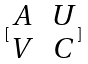<formula> <loc_0><loc_0><loc_500><loc_500>[ \begin{matrix} A & U \\ V & C \end{matrix} ]</formula> 